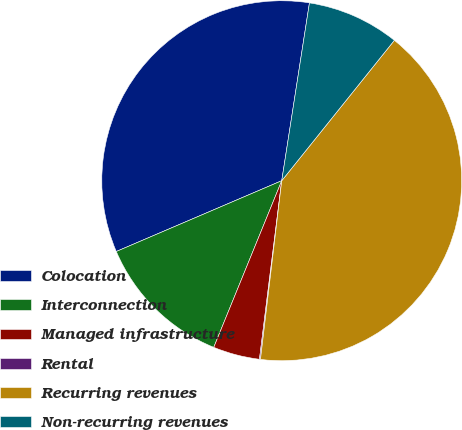<chart> <loc_0><loc_0><loc_500><loc_500><pie_chart><fcel>Colocation<fcel>Interconnection<fcel>Managed infrastructure<fcel>Rental<fcel>Recurring revenues<fcel>Non-recurring revenues<nl><fcel>33.9%<fcel>12.4%<fcel>4.19%<fcel>0.09%<fcel>41.13%<fcel>8.3%<nl></chart> 